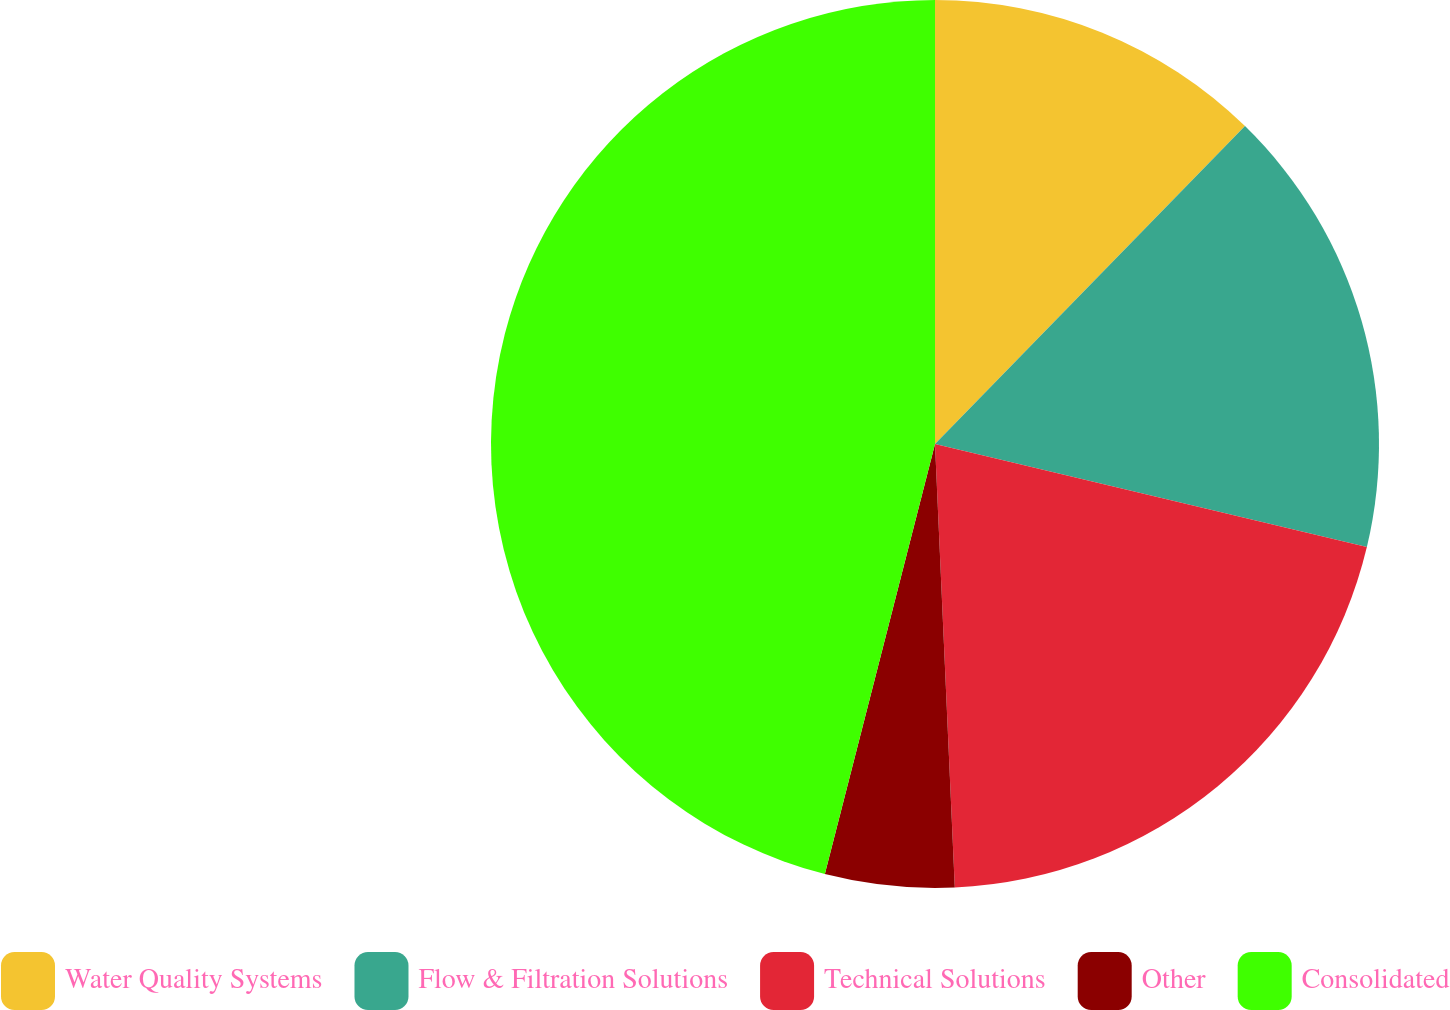<chart> <loc_0><loc_0><loc_500><loc_500><pie_chart><fcel>Water Quality Systems<fcel>Flow & Filtration Solutions<fcel>Technical Solutions<fcel>Other<fcel>Consolidated<nl><fcel>12.3%<fcel>16.43%<fcel>20.56%<fcel>4.7%<fcel>46.01%<nl></chart> 